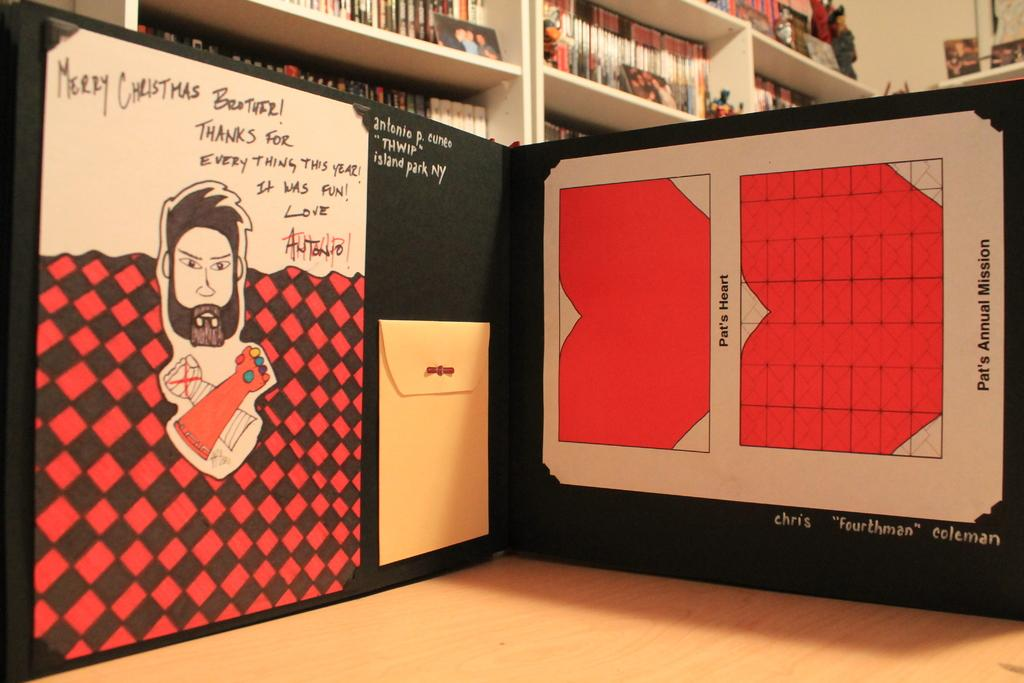<image>
Describe the image concisely. Merry Christmas is on a wall above a picture of a man. 